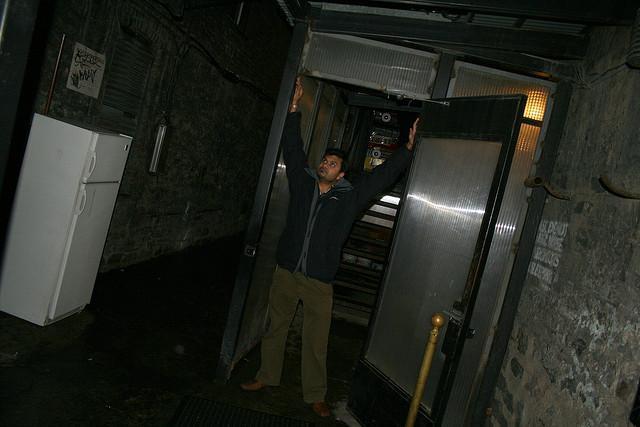How many arrows are in this picture?
Give a very brief answer. 0. How many yellow taxi cars are in this image?
Give a very brief answer. 0. 